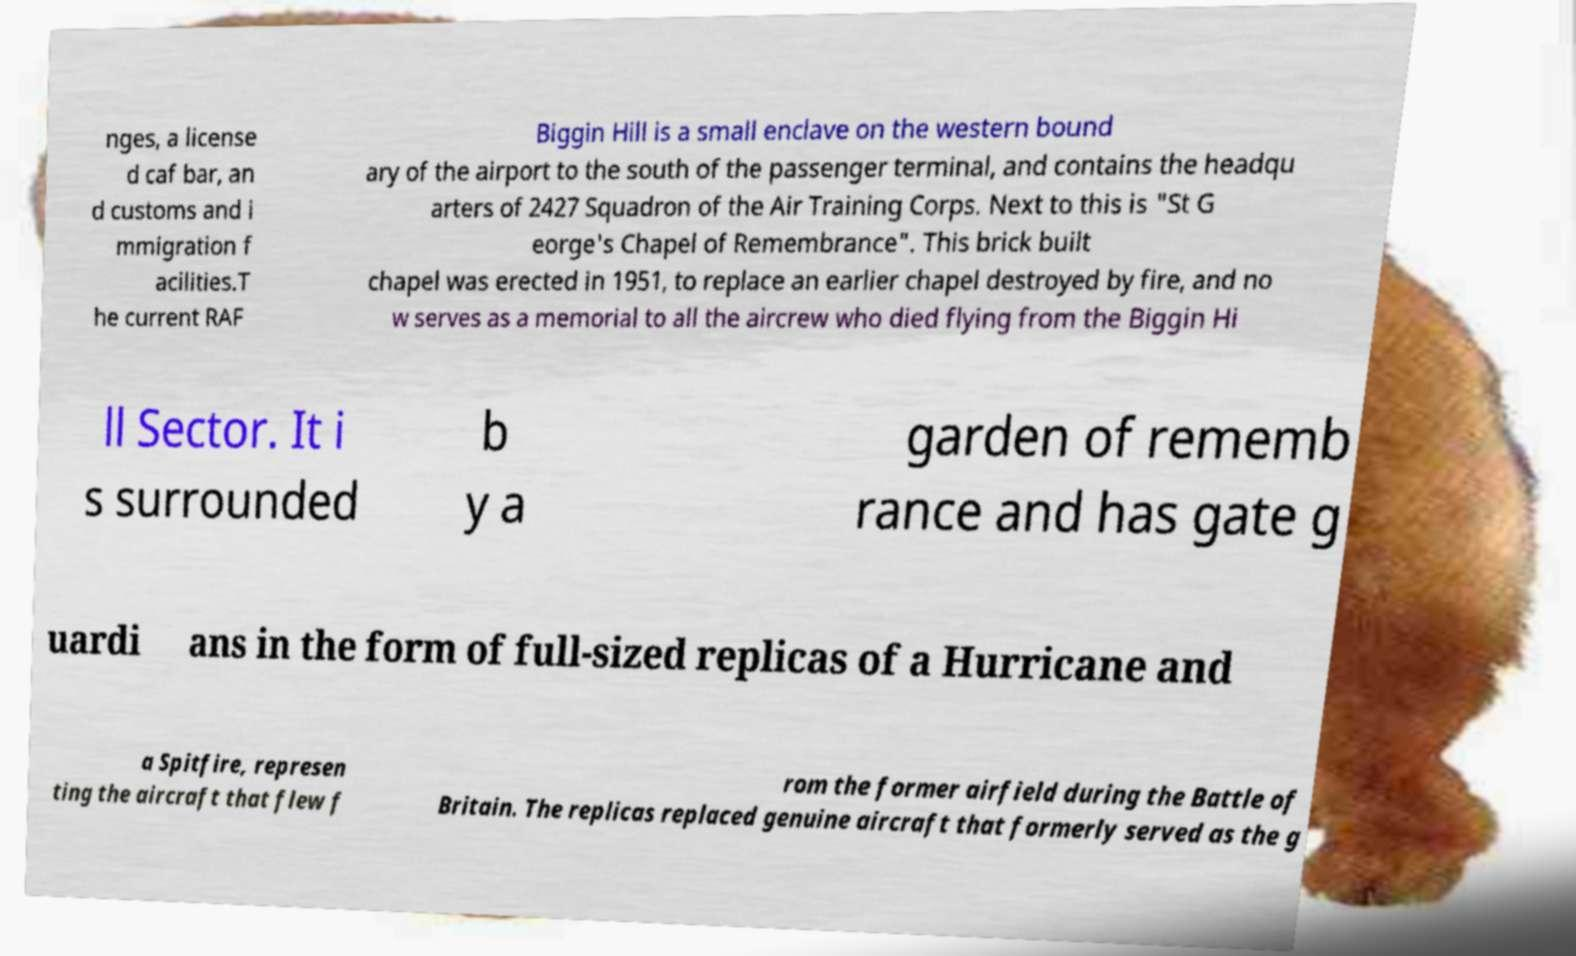For documentation purposes, I need the text within this image transcribed. Could you provide that? nges, a license d caf bar, an d customs and i mmigration f acilities.T he current RAF Biggin Hill is a small enclave on the western bound ary of the airport to the south of the passenger terminal, and contains the headqu arters of 2427 Squadron of the Air Training Corps. Next to this is "St G eorge's Chapel of Remembrance". This brick built chapel was erected in 1951, to replace an earlier chapel destroyed by fire, and no w serves as a memorial to all the aircrew who died flying from the Biggin Hi ll Sector. It i s surrounded b y a garden of rememb rance and has gate g uardi ans in the form of full-sized replicas of a Hurricane and a Spitfire, represen ting the aircraft that flew f rom the former airfield during the Battle of Britain. The replicas replaced genuine aircraft that formerly served as the g 